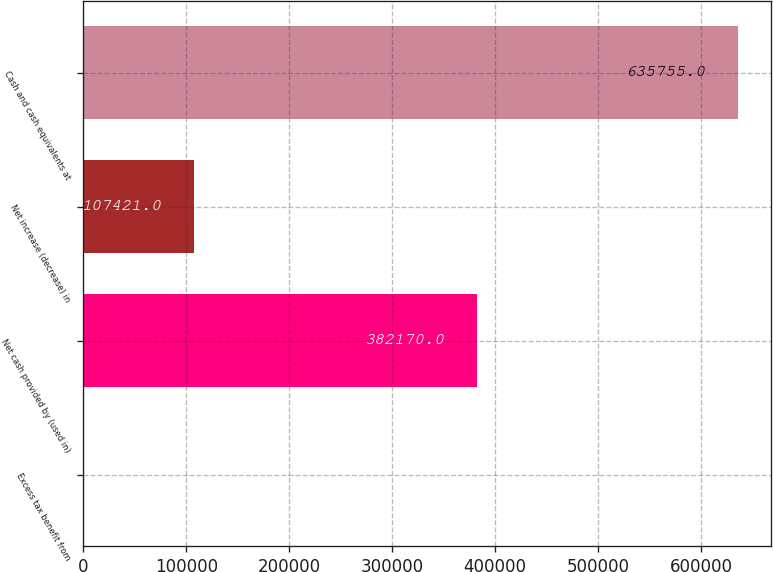Convert chart. <chart><loc_0><loc_0><loc_500><loc_500><bar_chart><fcel>Excess tax benefit from<fcel>Net cash provided by (used in)<fcel>Net increase (decrease) in<fcel>Cash and cash equivalents at<nl><fcel>297<fcel>382170<fcel>107421<fcel>635755<nl></chart> 